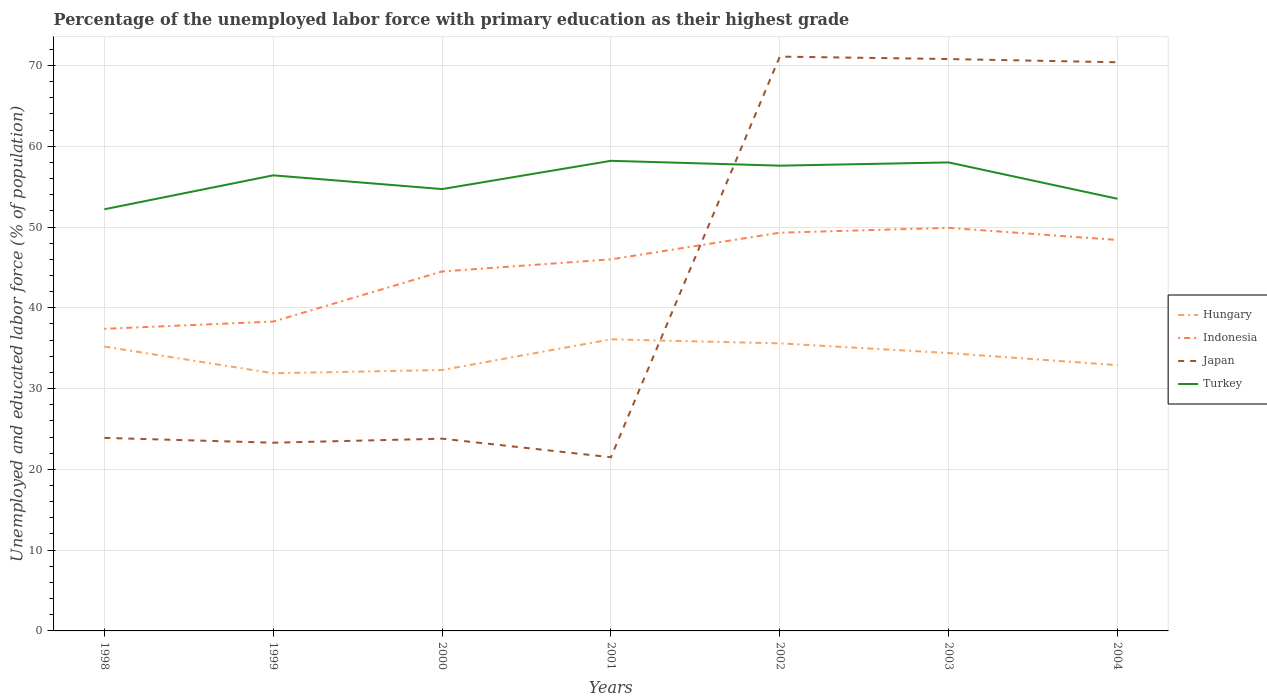Across all years, what is the maximum percentage of the unemployed labor force with primary education in Turkey?
Provide a succinct answer. 52.2. In which year was the percentage of the unemployed labor force with primary education in Indonesia maximum?
Keep it short and to the point. 1998. What is the total percentage of the unemployed labor force with primary education in Turkey in the graph?
Offer a very short reply. -0.4. What is the difference between the highest and the second highest percentage of the unemployed labor force with primary education in Hungary?
Your answer should be very brief. 4.2. What is the difference between the highest and the lowest percentage of the unemployed labor force with primary education in Japan?
Ensure brevity in your answer.  3. Is the percentage of the unemployed labor force with primary education in Turkey strictly greater than the percentage of the unemployed labor force with primary education in Hungary over the years?
Your answer should be compact. No. How many years are there in the graph?
Make the answer very short. 7. Are the values on the major ticks of Y-axis written in scientific E-notation?
Make the answer very short. No. What is the title of the graph?
Give a very brief answer. Percentage of the unemployed labor force with primary education as their highest grade. Does "Kiribati" appear as one of the legend labels in the graph?
Your answer should be very brief. No. What is the label or title of the X-axis?
Your answer should be compact. Years. What is the label or title of the Y-axis?
Your response must be concise. Unemployed and educated labor force (% of population). What is the Unemployed and educated labor force (% of population) of Hungary in 1998?
Provide a short and direct response. 35.2. What is the Unemployed and educated labor force (% of population) of Indonesia in 1998?
Your response must be concise. 37.4. What is the Unemployed and educated labor force (% of population) of Japan in 1998?
Your answer should be very brief. 23.9. What is the Unemployed and educated labor force (% of population) in Turkey in 1998?
Make the answer very short. 52.2. What is the Unemployed and educated labor force (% of population) in Hungary in 1999?
Your answer should be compact. 31.9. What is the Unemployed and educated labor force (% of population) of Indonesia in 1999?
Offer a very short reply. 38.3. What is the Unemployed and educated labor force (% of population) of Japan in 1999?
Provide a short and direct response. 23.3. What is the Unemployed and educated labor force (% of population) in Turkey in 1999?
Provide a succinct answer. 56.4. What is the Unemployed and educated labor force (% of population) in Hungary in 2000?
Provide a short and direct response. 32.3. What is the Unemployed and educated labor force (% of population) of Indonesia in 2000?
Provide a short and direct response. 44.5. What is the Unemployed and educated labor force (% of population) in Japan in 2000?
Your answer should be very brief. 23.8. What is the Unemployed and educated labor force (% of population) of Turkey in 2000?
Make the answer very short. 54.7. What is the Unemployed and educated labor force (% of population) in Hungary in 2001?
Offer a terse response. 36.1. What is the Unemployed and educated labor force (% of population) of Turkey in 2001?
Your answer should be compact. 58.2. What is the Unemployed and educated labor force (% of population) in Hungary in 2002?
Give a very brief answer. 35.6. What is the Unemployed and educated labor force (% of population) in Indonesia in 2002?
Make the answer very short. 49.3. What is the Unemployed and educated labor force (% of population) in Japan in 2002?
Your response must be concise. 71.1. What is the Unemployed and educated labor force (% of population) of Turkey in 2002?
Your answer should be compact. 57.6. What is the Unemployed and educated labor force (% of population) in Hungary in 2003?
Provide a short and direct response. 34.4. What is the Unemployed and educated labor force (% of population) of Indonesia in 2003?
Offer a very short reply. 49.9. What is the Unemployed and educated labor force (% of population) of Japan in 2003?
Provide a short and direct response. 70.8. What is the Unemployed and educated labor force (% of population) of Hungary in 2004?
Provide a succinct answer. 32.9. What is the Unemployed and educated labor force (% of population) in Indonesia in 2004?
Make the answer very short. 48.4. What is the Unemployed and educated labor force (% of population) of Japan in 2004?
Offer a terse response. 70.4. What is the Unemployed and educated labor force (% of population) in Turkey in 2004?
Make the answer very short. 53.5. Across all years, what is the maximum Unemployed and educated labor force (% of population) in Hungary?
Offer a terse response. 36.1. Across all years, what is the maximum Unemployed and educated labor force (% of population) in Indonesia?
Offer a terse response. 49.9. Across all years, what is the maximum Unemployed and educated labor force (% of population) in Japan?
Ensure brevity in your answer.  71.1. Across all years, what is the maximum Unemployed and educated labor force (% of population) in Turkey?
Keep it short and to the point. 58.2. Across all years, what is the minimum Unemployed and educated labor force (% of population) of Hungary?
Your answer should be compact. 31.9. Across all years, what is the minimum Unemployed and educated labor force (% of population) in Indonesia?
Provide a succinct answer. 37.4. Across all years, what is the minimum Unemployed and educated labor force (% of population) in Japan?
Provide a succinct answer. 21.5. Across all years, what is the minimum Unemployed and educated labor force (% of population) in Turkey?
Make the answer very short. 52.2. What is the total Unemployed and educated labor force (% of population) of Hungary in the graph?
Your answer should be compact. 238.4. What is the total Unemployed and educated labor force (% of population) in Indonesia in the graph?
Your response must be concise. 313.8. What is the total Unemployed and educated labor force (% of population) of Japan in the graph?
Ensure brevity in your answer.  304.8. What is the total Unemployed and educated labor force (% of population) of Turkey in the graph?
Your answer should be compact. 390.6. What is the difference between the Unemployed and educated labor force (% of population) of Indonesia in 1998 and that in 1999?
Keep it short and to the point. -0.9. What is the difference between the Unemployed and educated labor force (% of population) in Japan in 1998 and that in 1999?
Provide a short and direct response. 0.6. What is the difference between the Unemployed and educated labor force (% of population) of Turkey in 1998 and that in 1999?
Give a very brief answer. -4.2. What is the difference between the Unemployed and educated labor force (% of population) of Hungary in 1998 and that in 2000?
Give a very brief answer. 2.9. What is the difference between the Unemployed and educated labor force (% of population) in Japan in 1998 and that in 2000?
Make the answer very short. 0.1. What is the difference between the Unemployed and educated labor force (% of population) of Turkey in 1998 and that in 2000?
Your answer should be compact. -2.5. What is the difference between the Unemployed and educated labor force (% of population) of Hungary in 1998 and that in 2001?
Provide a short and direct response. -0.9. What is the difference between the Unemployed and educated labor force (% of population) of Indonesia in 1998 and that in 2001?
Ensure brevity in your answer.  -8.6. What is the difference between the Unemployed and educated labor force (% of population) of Japan in 1998 and that in 2001?
Provide a succinct answer. 2.4. What is the difference between the Unemployed and educated labor force (% of population) of Turkey in 1998 and that in 2001?
Offer a terse response. -6. What is the difference between the Unemployed and educated labor force (% of population) of Indonesia in 1998 and that in 2002?
Offer a very short reply. -11.9. What is the difference between the Unemployed and educated labor force (% of population) of Japan in 1998 and that in 2002?
Your answer should be very brief. -47.2. What is the difference between the Unemployed and educated labor force (% of population) in Hungary in 1998 and that in 2003?
Your response must be concise. 0.8. What is the difference between the Unemployed and educated labor force (% of population) in Japan in 1998 and that in 2003?
Keep it short and to the point. -46.9. What is the difference between the Unemployed and educated labor force (% of population) of Turkey in 1998 and that in 2003?
Provide a succinct answer. -5.8. What is the difference between the Unemployed and educated labor force (% of population) of Japan in 1998 and that in 2004?
Offer a terse response. -46.5. What is the difference between the Unemployed and educated labor force (% of population) in Hungary in 1999 and that in 2000?
Your answer should be compact. -0.4. What is the difference between the Unemployed and educated labor force (% of population) in Indonesia in 1999 and that in 2000?
Make the answer very short. -6.2. What is the difference between the Unemployed and educated labor force (% of population) in Turkey in 1999 and that in 2000?
Your answer should be very brief. 1.7. What is the difference between the Unemployed and educated labor force (% of population) in Indonesia in 1999 and that in 2001?
Provide a succinct answer. -7.7. What is the difference between the Unemployed and educated labor force (% of population) of Japan in 1999 and that in 2001?
Provide a short and direct response. 1.8. What is the difference between the Unemployed and educated labor force (% of population) of Hungary in 1999 and that in 2002?
Ensure brevity in your answer.  -3.7. What is the difference between the Unemployed and educated labor force (% of population) of Indonesia in 1999 and that in 2002?
Make the answer very short. -11. What is the difference between the Unemployed and educated labor force (% of population) of Japan in 1999 and that in 2002?
Make the answer very short. -47.8. What is the difference between the Unemployed and educated labor force (% of population) in Hungary in 1999 and that in 2003?
Offer a very short reply. -2.5. What is the difference between the Unemployed and educated labor force (% of population) in Indonesia in 1999 and that in 2003?
Provide a succinct answer. -11.6. What is the difference between the Unemployed and educated labor force (% of population) of Japan in 1999 and that in 2003?
Give a very brief answer. -47.5. What is the difference between the Unemployed and educated labor force (% of population) of Hungary in 1999 and that in 2004?
Make the answer very short. -1. What is the difference between the Unemployed and educated labor force (% of population) of Japan in 1999 and that in 2004?
Your response must be concise. -47.1. What is the difference between the Unemployed and educated labor force (% of population) in Hungary in 2000 and that in 2001?
Offer a very short reply. -3.8. What is the difference between the Unemployed and educated labor force (% of population) in Hungary in 2000 and that in 2002?
Offer a terse response. -3.3. What is the difference between the Unemployed and educated labor force (% of population) of Japan in 2000 and that in 2002?
Provide a succinct answer. -47.3. What is the difference between the Unemployed and educated labor force (% of population) of Turkey in 2000 and that in 2002?
Provide a succinct answer. -2.9. What is the difference between the Unemployed and educated labor force (% of population) of Indonesia in 2000 and that in 2003?
Give a very brief answer. -5.4. What is the difference between the Unemployed and educated labor force (% of population) of Japan in 2000 and that in 2003?
Your answer should be very brief. -47. What is the difference between the Unemployed and educated labor force (% of population) of Hungary in 2000 and that in 2004?
Keep it short and to the point. -0.6. What is the difference between the Unemployed and educated labor force (% of population) in Indonesia in 2000 and that in 2004?
Your answer should be compact. -3.9. What is the difference between the Unemployed and educated labor force (% of population) of Japan in 2000 and that in 2004?
Your answer should be very brief. -46.6. What is the difference between the Unemployed and educated labor force (% of population) of Japan in 2001 and that in 2002?
Provide a succinct answer. -49.6. What is the difference between the Unemployed and educated labor force (% of population) in Turkey in 2001 and that in 2002?
Your answer should be compact. 0.6. What is the difference between the Unemployed and educated labor force (% of population) of Japan in 2001 and that in 2003?
Provide a succinct answer. -49.3. What is the difference between the Unemployed and educated labor force (% of population) in Turkey in 2001 and that in 2003?
Ensure brevity in your answer.  0.2. What is the difference between the Unemployed and educated labor force (% of population) of Hungary in 2001 and that in 2004?
Offer a very short reply. 3.2. What is the difference between the Unemployed and educated labor force (% of population) of Japan in 2001 and that in 2004?
Provide a succinct answer. -48.9. What is the difference between the Unemployed and educated labor force (% of population) of Japan in 2002 and that in 2003?
Offer a terse response. 0.3. What is the difference between the Unemployed and educated labor force (% of population) in Turkey in 2002 and that in 2003?
Ensure brevity in your answer.  -0.4. What is the difference between the Unemployed and educated labor force (% of population) in Hungary in 2002 and that in 2004?
Give a very brief answer. 2.7. What is the difference between the Unemployed and educated labor force (% of population) in Indonesia in 2003 and that in 2004?
Make the answer very short. 1.5. What is the difference between the Unemployed and educated labor force (% of population) in Hungary in 1998 and the Unemployed and educated labor force (% of population) in Indonesia in 1999?
Keep it short and to the point. -3.1. What is the difference between the Unemployed and educated labor force (% of population) of Hungary in 1998 and the Unemployed and educated labor force (% of population) of Turkey in 1999?
Keep it short and to the point. -21.2. What is the difference between the Unemployed and educated labor force (% of population) in Japan in 1998 and the Unemployed and educated labor force (% of population) in Turkey in 1999?
Your answer should be very brief. -32.5. What is the difference between the Unemployed and educated labor force (% of population) of Hungary in 1998 and the Unemployed and educated labor force (% of population) of Indonesia in 2000?
Offer a very short reply. -9.3. What is the difference between the Unemployed and educated labor force (% of population) of Hungary in 1998 and the Unemployed and educated labor force (% of population) of Japan in 2000?
Offer a terse response. 11.4. What is the difference between the Unemployed and educated labor force (% of population) in Hungary in 1998 and the Unemployed and educated labor force (% of population) in Turkey in 2000?
Ensure brevity in your answer.  -19.5. What is the difference between the Unemployed and educated labor force (% of population) of Indonesia in 1998 and the Unemployed and educated labor force (% of population) of Japan in 2000?
Offer a very short reply. 13.6. What is the difference between the Unemployed and educated labor force (% of population) of Indonesia in 1998 and the Unemployed and educated labor force (% of population) of Turkey in 2000?
Make the answer very short. -17.3. What is the difference between the Unemployed and educated labor force (% of population) in Japan in 1998 and the Unemployed and educated labor force (% of population) in Turkey in 2000?
Ensure brevity in your answer.  -30.8. What is the difference between the Unemployed and educated labor force (% of population) of Hungary in 1998 and the Unemployed and educated labor force (% of population) of Indonesia in 2001?
Offer a terse response. -10.8. What is the difference between the Unemployed and educated labor force (% of population) of Hungary in 1998 and the Unemployed and educated labor force (% of population) of Turkey in 2001?
Provide a short and direct response. -23. What is the difference between the Unemployed and educated labor force (% of population) in Indonesia in 1998 and the Unemployed and educated labor force (% of population) in Turkey in 2001?
Your answer should be compact. -20.8. What is the difference between the Unemployed and educated labor force (% of population) in Japan in 1998 and the Unemployed and educated labor force (% of population) in Turkey in 2001?
Offer a very short reply. -34.3. What is the difference between the Unemployed and educated labor force (% of population) of Hungary in 1998 and the Unemployed and educated labor force (% of population) of Indonesia in 2002?
Ensure brevity in your answer.  -14.1. What is the difference between the Unemployed and educated labor force (% of population) in Hungary in 1998 and the Unemployed and educated labor force (% of population) in Japan in 2002?
Your answer should be very brief. -35.9. What is the difference between the Unemployed and educated labor force (% of population) of Hungary in 1998 and the Unemployed and educated labor force (% of population) of Turkey in 2002?
Offer a very short reply. -22.4. What is the difference between the Unemployed and educated labor force (% of population) in Indonesia in 1998 and the Unemployed and educated labor force (% of population) in Japan in 2002?
Ensure brevity in your answer.  -33.7. What is the difference between the Unemployed and educated labor force (% of population) in Indonesia in 1998 and the Unemployed and educated labor force (% of population) in Turkey in 2002?
Your answer should be very brief. -20.2. What is the difference between the Unemployed and educated labor force (% of population) in Japan in 1998 and the Unemployed and educated labor force (% of population) in Turkey in 2002?
Your answer should be compact. -33.7. What is the difference between the Unemployed and educated labor force (% of population) in Hungary in 1998 and the Unemployed and educated labor force (% of population) in Indonesia in 2003?
Your response must be concise. -14.7. What is the difference between the Unemployed and educated labor force (% of population) in Hungary in 1998 and the Unemployed and educated labor force (% of population) in Japan in 2003?
Keep it short and to the point. -35.6. What is the difference between the Unemployed and educated labor force (% of population) in Hungary in 1998 and the Unemployed and educated labor force (% of population) in Turkey in 2003?
Provide a succinct answer. -22.8. What is the difference between the Unemployed and educated labor force (% of population) in Indonesia in 1998 and the Unemployed and educated labor force (% of population) in Japan in 2003?
Make the answer very short. -33.4. What is the difference between the Unemployed and educated labor force (% of population) of Indonesia in 1998 and the Unemployed and educated labor force (% of population) of Turkey in 2003?
Give a very brief answer. -20.6. What is the difference between the Unemployed and educated labor force (% of population) of Japan in 1998 and the Unemployed and educated labor force (% of population) of Turkey in 2003?
Your answer should be compact. -34.1. What is the difference between the Unemployed and educated labor force (% of population) of Hungary in 1998 and the Unemployed and educated labor force (% of population) of Indonesia in 2004?
Your answer should be very brief. -13.2. What is the difference between the Unemployed and educated labor force (% of population) of Hungary in 1998 and the Unemployed and educated labor force (% of population) of Japan in 2004?
Your answer should be compact. -35.2. What is the difference between the Unemployed and educated labor force (% of population) of Hungary in 1998 and the Unemployed and educated labor force (% of population) of Turkey in 2004?
Offer a very short reply. -18.3. What is the difference between the Unemployed and educated labor force (% of population) of Indonesia in 1998 and the Unemployed and educated labor force (% of population) of Japan in 2004?
Your answer should be compact. -33. What is the difference between the Unemployed and educated labor force (% of population) in Indonesia in 1998 and the Unemployed and educated labor force (% of population) in Turkey in 2004?
Your answer should be very brief. -16.1. What is the difference between the Unemployed and educated labor force (% of population) in Japan in 1998 and the Unemployed and educated labor force (% of population) in Turkey in 2004?
Provide a short and direct response. -29.6. What is the difference between the Unemployed and educated labor force (% of population) of Hungary in 1999 and the Unemployed and educated labor force (% of population) of Japan in 2000?
Provide a short and direct response. 8.1. What is the difference between the Unemployed and educated labor force (% of population) of Hungary in 1999 and the Unemployed and educated labor force (% of population) of Turkey in 2000?
Your answer should be compact. -22.8. What is the difference between the Unemployed and educated labor force (% of population) in Indonesia in 1999 and the Unemployed and educated labor force (% of population) in Japan in 2000?
Give a very brief answer. 14.5. What is the difference between the Unemployed and educated labor force (% of population) in Indonesia in 1999 and the Unemployed and educated labor force (% of population) in Turkey in 2000?
Your answer should be compact. -16.4. What is the difference between the Unemployed and educated labor force (% of population) in Japan in 1999 and the Unemployed and educated labor force (% of population) in Turkey in 2000?
Keep it short and to the point. -31.4. What is the difference between the Unemployed and educated labor force (% of population) of Hungary in 1999 and the Unemployed and educated labor force (% of population) of Indonesia in 2001?
Offer a very short reply. -14.1. What is the difference between the Unemployed and educated labor force (% of population) of Hungary in 1999 and the Unemployed and educated labor force (% of population) of Japan in 2001?
Offer a very short reply. 10.4. What is the difference between the Unemployed and educated labor force (% of population) in Hungary in 1999 and the Unemployed and educated labor force (% of population) in Turkey in 2001?
Your response must be concise. -26.3. What is the difference between the Unemployed and educated labor force (% of population) in Indonesia in 1999 and the Unemployed and educated labor force (% of population) in Japan in 2001?
Offer a terse response. 16.8. What is the difference between the Unemployed and educated labor force (% of population) of Indonesia in 1999 and the Unemployed and educated labor force (% of population) of Turkey in 2001?
Make the answer very short. -19.9. What is the difference between the Unemployed and educated labor force (% of population) of Japan in 1999 and the Unemployed and educated labor force (% of population) of Turkey in 2001?
Provide a succinct answer. -34.9. What is the difference between the Unemployed and educated labor force (% of population) of Hungary in 1999 and the Unemployed and educated labor force (% of population) of Indonesia in 2002?
Give a very brief answer. -17.4. What is the difference between the Unemployed and educated labor force (% of population) in Hungary in 1999 and the Unemployed and educated labor force (% of population) in Japan in 2002?
Your answer should be very brief. -39.2. What is the difference between the Unemployed and educated labor force (% of population) of Hungary in 1999 and the Unemployed and educated labor force (% of population) of Turkey in 2002?
Give a very brief answer. -25.7. What is the difference between the Unemployed and educated labor force (% of population) in Indonesia in 1999 and the Unemployed and educated labor force (% of population) in Japan in 2002?
Your answer should be compact. -32.8. What is the difference between the Unemployed and educated labor force (% of population) of Indonesia in 1999 and the Unemployed and educated labor force (% of population) of Turkey in 2002?
Your response must be concise. -19.3. What is the difference between the Unemployed and educated labor force (% of population) in Japan in 1999 and the Unemployed and educated labor force (% of population) in Turkey in 2002?
Provide a succinct answer. -34.3. What is the difference between the Unemployed and educated labor force (% of population) in Hungary in 1999 and the Unemployed and educated labor force (% of population) in Japan in 2003?
Ensure brevity in your answer.  -38.9. What is the difference between the Unemployed and educated labor force (% of population) of Hungary in 1999 and the Unemployed and educated labor force (% of population) of Turkey in 2003?
Make the answer very short. -26.1. What is the difference between the Unemployed and educated labor force (% of population) of Indonesia in 1999 and the Unemployed and educated labor force (% of population) of Japan in 2003?
Ensure brevity in your answer.  -32.5. What is the difference between the Unemployed and educated labor force (% of population) of Indonesia in 1999 and the Unemployed and educated labor force (% of population) of Turkey in 2003?
Your answer should be very brief. -19.7. What is the difference between the Unemployed and educated labor force (% of population) in Japan in 1999 and the Unemployed and educated labor force (% of population) in Turkey in 2003?
Provide a succinct answer. -34.7. What is the difference between the Unemployed and educated labor force (% of population) of Hungary in 1999 and the Unemployed and educated labor force (% of population) of Indonesia in 2004?
Give a very brief answer. -16.5. What is the difference between the Unemployed and educated labor force (% of population) in Hungary in 1999 and the Unemployed and educated labor force (% of population) in Japan in 2004?
Your response must be concise. -38.5. What is the difference between the Unemployed and educated labor force (% of population) of Hungary in 1999 and the Unemployed and educated labor force (% of population) of Turkey in 2004?
Provide a succinct answer. -21.6. What is the difference between the Unemployed and educated labor force (% of population) of Indonesia in 1999 and the Unemployed and educated labor force (% of population) of Japan in 2004?
Your response must be concise. -32.1. What is the difference between the Unemployed and educated labor force (% of population) in Indonesia in 1999 and the Unemployed and educated labor force (% of population) in Turkey in 2004?
Provide a short and direct response. -15.2. What is the difference between the Unemployed and educated labor force (% of population) of Japan in 1999 and the Unemployed and educated labor force (% of population) of Turkey in 2004?
Ensure brevity in your answer.  -30.2. What is the difference between the Unemployed and educated labor force (% of population) in Hungary in 2000 and the Unemployed and educated labor force (% of population) in Indonesia in 2001?
Your response must be concise. -13.7. What is the difference between the Unemployed and educated labor force (% of population) of Hungary in 2000 and the Unemployed and educated labor force (% of population) of Japan in 2001?
Make the answer very short. 10.8. What is the difference between the Unemployed and educated labor force (% of population) in Hungary in 2000 and the Unemployed and educated labor force (% of population) in Turkey in 2001?
Ensure brevity in your answer.  -25.9. What is the difference between the Unemployed and educated labor force (% of population) in Indonesia in 2000 and the Unemployed and educated labor force (% of population) in Japan in 2001?
Your answer should be very brief. 23. What is the difference between the Unemployed and educated labor force (% of population) in Indonesia in 2000 and the Unemployed and educated labor force (% of population) in Turkey in 2001?
Your answer should be compact. -13.7. What is the difference between the Unemployed and educated labor force (% of population) in Japan in 2000 and the Unemployed and educated labor force (% of population) in Turkey in 2001?
Offer a terse response. -34.4. What is the difference between the Unemployed and educated labor force (% of population) of Hungary in 2000 and the Unemployed and educated labor force (% of population) of Indonesia in 2002?
Your response must be concise. -17. What is the difference between the Unemployed and educated labor force (% of population) in Hungary in 2000 and the Unemployed and educated labor force (% of population) in Japan in 2002?
Ensure brevity in your answer.  -38.8. What is the difference between the Unemployed and educated labor force (% of population) in Hungary in 2000 and the Unemployed and educated labor force (% of population) in Turkey in 2002?
Give a very brief answer. -25.3. What is the difference between the Unemployed and educated labor force (% of population) in Indonesia in 2000 and the Unemployed and educated labor force (% of population) in Japan in 2002?
Offer a very short reply. -26.6. What is the difference between the Unemployed and educated labor force (% of population) in Japan in 2000 and the Unemployed and educated labor force (% of population) in Turkey in 2002?
Provide a succinct answer. -33.8. What is the difference between the Unemployed and educated labor force (% of population) in Hungary in 2000 and the Unemployed and educated labor force (% of population) in Indonesia in 2003?
Offer a terse response. -17.6. What is the difference between the Unemployed and educated labor force (% of population) in Hungary in 2000 and the Unemployed and educated labor force (% of population) in Japan in 2003?
Your response must be concise. -38.5. What is the difference between the Unemployed and educated labor force (% of population) in Hungary in 2000 and the Unemployed and educated labor force (% of population) in Turkey in 2003?
Make the answer very short. -25.7. What is the difference between the Unemployed and educated labor force (% of population) of Indonesia in 2000 and the Unemployed and educated labor force (% of population) of Japan in 2003?
Make the answer very short. -26.3. What is the difference between the Unemployed and educated labor force (% of population) of Indonesia in 2000 and the Unemployed and educated labor force (% of population) of Turkey in 2003?
Offer a terse response. -13.5. What is the difference between the Unemployed and educated labor force (% of population) of Japan in 2000 and the Unemployed and educated labor force (% of population) of Turkey in 2003?
Offer a terse response. -34.2. What is the difference between the Unemployed and educated labor force (% of population) of Hungary in 2000 and the Unemployed and educated labor force (% of population) of Indonesia in 2004?
Provide a short and direct response. -16.1. What is the difference between the Unemployed and educated labor force (% of population) of Hungary in 2000 and the Unemployed and educated labor force (% of population) of Japan in 2004?
Provide a succinct answer. -38.1. What is the difference between the Unemployed and educated labor force (% of population) in Hungary in 2000 and the Unemployed and educated labor force (% of population) in Turkey in 2004?
Make the answer very short. -21.2. What is the difference between the Unemployed and educated labor force (% of population) in Indonesia in 2000 and the Unemployed and educated labor force (% of population) in Japan in 2004?
Keep it short and to the point. -25.9. What is the difference between the Unemployed and educated labor force (% of population) of Indonesia in 2000 and the Unemployed and educated labor force (% of population) of Turkey in 2004?
Provide a short and direct response. -9. What is the difference between the Unemployed and educated labor force (% of population) in Japan in 2000 and the Unemployed and educated labor force (% of population) in Turkey in 2004?
Offer a very short reply. -29.7. What is the difference between the Unemployed and educated labor force (% of population) in Hungary in 2001 and the Unemployed and educated labor force (% of population) in Indonesia in 2002?
Your response must be concise. -13.2. What is the difference between the Unemployed and educated labor force (% of population) of Hungary in 2001 and the Unemployed and educated labor force (% of population) of Japan in 2002?
Your response must be concise. -35. What is the difference between the Unemployed and educated labor force (% of population) in Hungary in 2001 and the Unemployed and educated labor force (% of population) in Turkey in 2002?
Offer a very short reply. -21.5. What is the difference between the Unemployed and educated labor force (% of population) in Indonesia in 2001 and the Unemployed and educated labor force (% of population) in Japan in 2002?
Give a very brief answer. -25.1. What is the difference between the Unemployed and educated labor force (% of population) in Indonesia in 2001 and the Unemployed and educated labor force (% of population) in Turkey in 2002?
Provide a short and direct response. -11.6. What is the difference between the Unemployed and educated labor force (% of population) in Japan in 2001 and the Unemployed and educated labor force (% of population) in Turkey in 2002?
Provide a short and direct response. -36.1. What is the difference between the Unemployed and educated labor force (% of population) in Hungary in 2001 and the Unemployed and educated labor force (% of population) in Indonesia in 2003?
Your response must be concise. -13.8. What is the difference between the Unemployed and educated labor force (% of population) of Hungary in 2001 and the Unemployed and educated labor force (% of population) of Japan in 2003?
Provide a short and direct response. -34.7. What is the difference between the Unemployed and educated labor force (% of population) in Hungary in 2001 and the Unemployed and educated labor force (% of population) in Turkey in 2003?
Your answer should be compact. -21.9. What is the difference between the Unemployed and educated labor force (% of population) in Indonesia in 2001 and the Unemployed and educated labor force (% of population) in Japan in 2003?
Ensure brevity in your answer.  -24.8. What is the difference between the Unemployed and educated labor force (% of population) in Indonesia in 2001 and the Unemployed and educated labor force (% of population) in Turkey in 2003?
Make the answer very short. -12. What is the difference between the Unemployed and educated labor force (% of population) in Japan in 2001 and the Unemployed and educated labor force (% of population) in Turkey in 2003?
Keep it short and to the point. -36.5. What is the difference between the Unemployed and educated labor force (% of population) of Hungary in 2001 and the Unemployed and educated labor force (% of population) of Japan in 2004?
Ensure brevity in your answer.  -34.3. What is the difference between the Unemployed and educated labor force (% of population) in Hungary in 2001 and the Unemployed and educated labor force (% of population) in Turkey in 2004?
Give a very brief answer. -17.4. What is the difference between the Unemployed and educated labor force (% of population) in Indonesia in 2001 and the Unemployed and educated labor force (% of population) in Japan in 2004?
Provide a short and direct response. -24.4. What is the difference between the Unemployed and educated labor force (% of population) of Japan in 2001 and the Unemployed and educated labor force (% of population) of Turkey in 2004?
Offer a very short reply. -32. What is the difference between the Unemployed and educated labor force (% of population) in Hungary in 2002 and the Unemployed and educated labor force (% of population) in Indonesia in 2003?
Provide a succinct answer. -14.3. What is the difference between the Unemployed and educated labor force (% of population) of Hungary in 2002 and the Unemployed and educated labor force (% of population) of Japan in 2003?
Give a very brief answer. -35.2. What is the difference between the Unemployed and educated labor force (% of population) of Hungary in 2002 and the Unemployed and educated labor force (% of population) of Turkey in 2003?
Offer a terse response. -22.4. What is the difference between the Unemployed and educated labor force (% of population) of Indonesia in 2002 and the Unemployed and educated labor force (% of population) of Japan in 2003?
Make the answer very short. -21.5. What is the difference between the Unemployed and educated labor force (% of population) of Japan in 2002 and the Unemployed and educated labor force (% of population) of Turkey in 2003?
Provide a short and direct response. 13.1. What is the difference between the Unemployed and educated labor force (% of population) in Hungary in 2002 and the Unemployed and educated labor force (% of population) in Japan in 2004?
Provide a succinct answer. -34.8. What is the difference between the Unemployed and educated labor force (% of population) of Hungary in 2002 and the Unemployed and educated labor force (% of population) of Turkey in 2004?
Offer a terse response. -17.9. What is the difference between the Unemployed and educated labor force (% of population) of Indonesia in 2002 and the Unemployed and educated labor force (% of population) of Japan in 2004?
Offer a very short reply. -21.1. What is the difference between the Unemployed and educated labor force (% of population) in Hungary in 2003 and the Unemployed and educated labor force (% of population) in Japan in 2004?
Offer a terse response. -36. What is the difference between the Unemployed and educated labor force (% of population) in Hungary in 2003 and the Unemployed and educated labor force (% of population) in Turkey in 2004?
Offer a very short reply. -19.1. What is the difference between the Unemployed and educated labor force (% of population) of Indonesia in 2003 and the Unemployed and educated labor force (% of population) of Japan in 2004?
Keep it short and to the point. -20.5. What is the difference between the Unemployed and educated labor force (% of population) in Japan in 2003 and the Unemployed and educated labor force (% of population) in Turkey in 2004?
Your response must be concise. 17.3. What is the average Unemployed and educated labor force (% of population) in Hungary per year?
Your response must be concise. 34.06. What is the average Unemployed and educated labor force (% of population) in Indonesia per year?
Offer a terse response. 44.83. What is the average Unemployed and educated labor force (% of population) in Japan per year?
Give a very brief answer. 43.54. What is the average Unemployed and educated labor force (% of population) in Turkey per year?
Your response must be concise. 55.8. In the year 1998, what is the difference between the Unemployed and educated labor force (% of population) in Hungary and Unemployed and educated labor force (% of population) in Indonesia?
Offer a very short reply. -2.2. In the year 1998, what is the difference between the Unemployed and educated labor force (% of population) in Hungary and Unemployed and educated labor force (% of population) in Turkey?
Provide a short and direct response. -17. In the year 1998, what is the difference between the Unemployed and educated labor force (% of population) of Indonesia and Unemployed and educated labor force (% of population) of Turkey?
Offer a terse response. -14.8. In the year 1998, what is the difference between the Unemployed and educated labor force (% of population) of Japan and Unemployed and educated labor force (% of population) of Turkey?
Offer a terse response. -28.3. In the year 1999, what is the difference between the Unemployed and educated labor force (% of population) of Hungary and Unemployed and educated labor force (% of population) of Turkey?
Make the answer very short. -24.5. In the year 1999, what is the difference between the Unemployed and educated labor force (% of population) in Indonesia and Unemployed and educated labor force (% of population) in Turkey?
Provide a short and direct response. -18.1. In the year 1999, what is the difference between the Unemployed and educated labor force (% of population) in Japan and Unemployed and educated labor force (% of population) in Turkey?
Provide a succinct answer. -33.1. In the year 2000, what is the difference between the Unemployed and educated labor force (% of population) in Hungary and Unemployed and educated labor force (% of population) in Japan?
Give a very brief answer. 8.5. In the year 2000, what is the difference between the Unemployed and educated labor force (% of population) of Hungary and Unemployed and educated labor force (% of population) of Turkey?
Your response must be concise. -22.4. In the year 2000, what is the difference between the Unemployed and educated labor force (% of population) in Indonesia and Unemployed and educated labor force (% of population) in Japan?
Provide a succinct answer. 20.7. In the year 2000, what is the difference between the Unemployed and educated labor force (% of population) in Indonesia and Unemployed and educated labor force (% of population) in Turkey?
Your answer should be very brief. -10.2. In the year 2000, what is the difference between the Unemployed and educated labor force (% of population) of Japan and Unemployed and educated labor force (% of population) of Turkey?
Make the answer very short. -30.9. In the year 2001, what is the difference between the Unemployed and educated labor force (% of population) in Hungary and Unemployed and educated labor force (% of population) in Indonesia?
Your answer should be compact. -9.9. In the year 2001, what is the difference between the Unemployed and educated labor force (% of population) of Hungary and Unemployed and educated labor force (% of population) of Turkey?
Provide a short and direct response. -22.1. In the year 2001, what is the difference between the Unemployed and educated labor force (% of population) of Indonesia and Unemployed and educated labor force (% of population) of Turkey?
Keep it short and to the point. -12.2. In the year 2001, what is the difference between the Unemployed and educated labor force (% of population) of Japan and Unemployed and educated labor force (% of population) of Turkey?
Give a very brief answer. -36.7. In the year 2002, what is the difference between the Unemployed and educated labor force (% of population) in Hungary and Unemployed and educated labor force (% of population) in Indonesia?
Provide a short and direct response. -13.7. In the year 2002, what is the difference between the Unemployed and educated labor force (% of population) of Hungary and Unemployed and educated labor force (% of population) of Japan?
Your answer should be very brief. -35.5. In the year 2002, what is the difference between the Unemployed and educated labor force (% of population) in Indonesia and Unemployed and educated labor force (% of population) in Japan?
Give a very brief answer. -21.8. In the year 2002, what is the difference between the Unemployed and educated labor force (% of population) in Japan and Unemployed and educated labor force (% of population) in Turkey?
Ensure brevity in your answer.  13.5. In the year 2003, what is the difference between the Unemployed and educated labor force (% of population) in Hungary and Unemployed and educated labor force (% of population) in Indonesia?
Provide a short and direct response. -15.5. In the year 2003, what is the difference between the Unemployed and educated labor force (% of population) in Hungary and Unemployed and educated labor force (% of population) in Japan?
Ensure brevity in your answer.  -36.4. In the year 2003, what is the difference between the Unemployed and educated labor force (% of population) of Hungary and Unemployed and educated labor force (% of population) of Turkey?
Your answer should be compact. -23.6. In the year 2003, what is the difference between the Unemployed and educated labor force (% of population) in Indonesia and Unemployed and educated labor force (% of population) in Japan?
Provide a short and direct response. -20.9. In the year 2003, what is the difference between the Unemployed and educated labor force (% of population) of Japan and Unemployed and educated labor force (% of population) of Turkey?
Provide a short and direct response. 12.8. In the year 2004, what is the difference between the Unemployed and educated labor force (% of population) of Hungary and Unemployed and educated labor force (% of population) of Indonesia?
Offer a very short reply. -15.5. In the year 2004, what is the difference between the Unemployed and educated labor force (% of population) in Hungary and Unemployed and educated labor force (% of population) in Japan?
Your answer should be compact. -37.5. In the year 2004, what is the difference between the Unemployed and educated labor force (% of population) of Hungary and Unemployed and educated labor force (% of population) of Turkey?
Keep it short and to the point. -20.6. In the year 2004, what is the difference between the Unemployed and educated labor force (% of population) in Indonesia and Unemployed and educated labor force (% of population) in Turkey?
Your answer should be very brief. -5.1. In the year 2004, what is the difference between the Unemployed and educated labor force (% of population) of Japan and Unemployed and educated labor force (% of population) of Turkey?
Offer a terse response. 16.9. What is the ratio of the Unemployed and educated labor force (% of population) in Hungary in 1998 to that in 1999?
Your answer should be compact. 1.1. What is the ratio of the Unemployed and educated labor force (% of population) in Indonesia in 1998 to that in 1999?
Your response must be concise. 0.98. What is the ratio of the Unemployed and educated labor force (% of population) of Japan in 1998 to that in 1999?
Your answer should be compact. 1.03. What is the ratio of the Unemployed and educated labor force (% of population) in Turkey in 1998 to that in 1999?
Offer a terse response. 0.93. What is the ratio of the Unemployed and educated labor force (% of population) in Hungary in 1998 to that in 2000?
Keep it short and to the point. 1.09. What is the ratio of the Unemployed and educated labor force (% of population) of Indonesia in 1998 to that in 2000?
Provide a succinct answer. 0.84. What is the ratio of the Unemployed and educated labor force (% of population) of Turkey in 1998 to that in 2000?
Your response must be concise. 0.95. What is the ratio of the Unemployed and educated labor force (% of population) in Hungary in 1998 to that in 2001?
Offer a terse response. 0.98. What is the ratio of the Unemployed and educated labor force (% of population) of Indonesia in 1998 to that in 2001?
Provide a succinct answer. 0.81. What is the ratio of the Unemployed and educated labor force (% of population) of Japan in 1998 to that in 2001?
Your answer should be very brief. 1.11. What is the ratio of the Unemployed and educated labor force (% of population) of Turkey in 1998 to that in 2001?
Ensure brevity in your answer.  0.9. What is the ratio of the Unemployed and educated labor force (% of population) in Indonesia in 1998 to that in 2002?
Offer a terse response. 0.76. What is the ratio of the Unemployed and educated labor force (% of population) in Japan in 1998 to that in 2002?
Provide a short and direct response. 0.34. What is the ratio of the Unemployed and educated labor force (% of population) in Turkey in 1998 to that in 2002?
Offer a very short reply. 0.91. What is the ratio of the Unemployed and educated labor force (% of population) in Hungary in 1998 to that in 2003?
Your answer should be very brief. 1.02. What is the ratio of the Unemployed and educated labor force (% of population) of Indonesia in 1998 to that in 2003?
Your answer should be very brief. 0.75. What is the ratio of the Unemployed and educated labor force (% of population) in Japan in 1998 to that in 2003?
Give a very brief answer. 0.34. What is the ratio of the Unemployed and educated labor force (% of population) in Hungary in 1998 to that in 2004?
Your response must be concise. 1.07. What is the ratio of the Unemployed and educated labor force (% of population) in Indonesia in 1998 to that in 2004?
Your response must be concise. 0.77. What is the ratio of the Unemployed and educated labor force (% of population) of Japan in 1998 to that in 2004?
Provide a succinct answer. 0.34. What is the ratio of the Unemployed and educated labor force (% of population) of Turkey in 1998 to that in 2004?
Offer a terse response. 0.98. What is the ratio of the Unemployed and educated labor force (% of population) of Hungary in 1999 to that in 2000?
Keep it short and to the point. 0.99. What is the ratio of the Unemployed and educated labor force (% of population) of Indonesia in 1999 to that in 2000?
Provide a short and direct response. 0.86. What is the ratio of the Unemployed and educated labor force (% of population) in Turkey in 1999 to that in 2000?
Your answer should be very brief. 1.03. What is the ratio of the Unemployed and educated labor force (% of population) in Hungary in 1999 to that in 2001?
Provide a short and direct response. 0.88. What is the ratio of the Unemployed and educated labor force (% of population) in Indonesia in 1999 to that in 2001?
Offer a terse response. 0.83. What is the ratio of the Unemployed and educated labor force (% of population) in Japan in 1999 to that in 2001?
Your answer should be very brief. 1.08. What is the ratio of the Unemployed and educated labor force (% of population) in Turkey in 1999 to that in 2001?
Ensure brevity in your answer.  0.97. What is the ratio of the Unemployed and educated labor force (% of population) in Hungary in 1999 to that in 2002?
Offer a terse response. 0.9. What is the ratio of the Unemployed and educated labor force (% of population) in Indonesia in 1999 to that in 2002?
Offer a terse response. 0.78. What is the ratio of the Unemployed and educated labor force (% of population) of Japan in 1999 to that in 2002?
Provide a succinct answer. 0.33. What is the ratio of the Unemployed and educated labor force (% of population) of Turkey in 1999 to that in 2002?
Give a very brief answer. 0.98. What is the ratio of the Unemployed and educated labor force (% of population) in Hungary in 1999 to that in 2003?
Provide a short and direct response. 0.93. What is the ratio of the Unemployed and educated labor force (% of population) of Indonesia in 1999 to that in 2003?
Make the answer very short. 0.77. What is the ratio of the Unemployed and educated labor force (% of population) in Japan in 1999 to that in 2003?
Provide a succinct answer. 0.33. What is the ratio of the Unemployed and educated labor force (% of population) of Turkey in 1999 to that in 2003?
Give a very brief answer. 0.97. What is the ratio of the Unemployed and educated labor force (% of population) of Hungary in 1999 to that in 2004?
Your response must be concise. 0.97. What is the ratio of the Unemployed and educated labor force (% of population) in Indonesia in 1999 to that in 2004?
Keep it short and to the point. 0.79. What is the ratio of the Unemployed and educated labor force (% of population) of Japan in 1999 to that in 2004?
Make the answer very short. 0.33. What is the ratio of the Unemployed and educated labor force (% of population) in Turkey in 1999 to that in 2004?
Your answer should be compact. 1.05. What is the ratio of the Unemployed and educated labor force (% of population) of Hungary in 2000 to that in 2001?
Your response must be concise. 0.89. What is the ratio of the Unemployed and educated labor force (% of population) in Indonesia in 2000 to that in 2001?
Provide a short and direct response. 0.97. What is the ratio of the Unemployed and educated labor force (% of population) in Japan in 2000 to that in 2001?
Provide a succinct answer. 1.11. What is the ratio of the Unemployed and educated labor force (% of population) in Turkey in 2000 to that in 2001?
Provide a short and direct response. 0.94. What is the ratio of the Unemployed and educated labor force (% of population) in Hungary in 2000 to that in 2002?
Make the answer very short. 0.91. What is the ratio of the Unemployed and educated labor force (% of population) in Indonesia in 2000 to that in 2002?
Provide a short and direct response. 0.9. What is the ratio of the Unemployed and educated labor force (% of population) of Japan in 2000 to that in 2002?
Ensure brevity in your answer.  0.33. What is the ratio of the Unemployed and educated labor force (% of population) of Turkey in 2000 to that in 2002?
Offer a terse response. 0.95. What is the ratio of the Unemployed and educated labor force (% of population) in Hungary in 2000 to that in 2003?
Provide a succinct answer. 0.94. What is the ratio of the Unemployed and educated labor force (% of population) in Indonesia in 2000 to that in 2003?
Provide a succinct answer. 0.89. What is the ratio of the Unemployed and educated labor force (% of population) in Japan in 2000 to that in 2003?
Offer a terse response. 0.34. What is the ratio of the Unemployed and educated labor force (% of population) in Turkey in 2000 to that in 2003?
Provide a short and direct response. 0.94. What is the ratio of the Unemployed and educated labor force (% of population) of Hungary in 2000 to that in 2004?
Offer a very short reply. 0.98. What is the ratio of the Unemployed and educated labor force (% of population) in Indonesia in 2000 to that in 2004?
Keep it short and to the point. 0.92. What is the ratio of the Unemployed and educated labor force (% of population) of Japan in 2000 to that in 2004?
Offer a terse response. 0.34. What is the ratio of the Unemployed and educated labor force (% of population) of Turkey in 2000 to that in 2004?
Provide a succinct answer. 1.02. What is the ratio of the Unemployed and educated labor force (% of population) of Hungary in 2001 to that in 2002?
Your response must be concise. 1.01. What is the ratio of the Unemployed and educated labor force (% of population) in Indonesia in 2001 to that in 2002?
Ensure brevity in your answer.  0.93. What is the ratio of the Unemployed and educated labor force (% of population) in Japan in 2001 to that in 2002?
Offer a terse response. 0.3. What is the ratio of the Unemployed and educated labor force (% of population) in Turkey in 2001 to that in 2002?
Make the answer very short. 1.01. What is the ratio of the Unemployed and educated labor force (% of population) in Hungary in 2001 to that in 2003?
Provide a short and direct response. 1.05. What is the ratio of the Unemployed and educated labor force (% of population) of Indonesia in 2001 to that in 2003?
Your answer should be compact. 0.92. What is the ratio of the Unemployed and educated labor force (% of population) of Japan in 2001 to that in 2003?
Give a very brief answer. 0.3. What is the ratio of the Unemployed and educated labor force (% of population) in Turkey in 2001 to that in 2003?
Offer a very short reply. 1. What is the ratio of the Unemployed and educated labor force (% of population) of Hungary in 2001 to that in 2004?
Provide a succinct answer. 1.1. What is the ratio of the Unemployed and educated labor force (% of population) of Indonesia in 2001 to that in 2004?
Your response must be concise. 0.95. What is the ratio of the Unemployed and educated labor force (% of population) of Japan in 2001 to that in 2004?
Your response must be concise. 0.31. What is the ratio of the Unemployed and educated labor force (% of population) in Turkey in 2001 to that in 2004?
Provide a succinct answer. 1.09. What is the ratio of the Unemployed and educated labor force (% of population) of Hungary in 2002 to that in 2003?
Provide a succinct answer. 1.03. What is the ratio of the Unemployed and educated labor force (% of population) of Turkey in 2002 to that in 2003?
Offer a very short reply. 0.99. What is the ratio of the Unemployed and educated labor force (% of population) of Hungary in 2002 to that in 2004?
Ensure brevity in your answer.  1.08. What is the ratio of the Unemployed and educated labor force (% of population) of Indonesia in 2002 to that in 2004?
Offer a terse response. 1.02. What is the ratio of the Unemployed and educated labor force (% of population) in Japan in 2002 to that in 2004?
Offer a terse response. 1.01. What is the ratio of the Unemployed and educated labor force (% of population) in Turkey in 2002 to that in 2004?
Give a very brief answer. 1.08. What is the ratio of the Unemployed and educated labor force (% of population) in Hungary in 2003 to that in 2004?
Keep it short and to the point. 1.05. What is the ratio of the Unemployed and educated labor force (% of population) of Indonesia in 2003 to that in 2004?
Make the answer very short. 1.03. What is the ratio of the Unemployed and educated labor force (% of population) in Japan in 2003 to that in 2004?
Offer a very short reply. 1.01. What is the ratio of the Unemployed and educated labor force (% of population) of Turkey in 2003 to that in 2004?
Give a very brief answer. 1.08. What is the difference between the highest and the second highest Unemployed and educated labor force (% of population) of Hungary?
Give a very brief answer. 0.5. What is the difference between the highest and the second highest Unemployed and educated labor force (% of population) of Indonesia?
Offer a terse response. 0.6. What is the difference between the highest and the second highest Unemployed and educated labor force (% of population) in Japan?
Keep it short and to the point. 0.3. What is the difference between the highest and the second highest Unemployed and educated labor force (% of population) of Turkey?
Offer a very short reply. 0.2. What is the difference between the highest and the lowest Unemployed and educated labor force (% of population) of Hungary?
Provide a short and direct response. 4.2. What is the difference between the highest and the lowest Unemployed and educated labor force (% of population) in Japan?
Ensure brevity in your answer.  49.6. What is the difference between the highest and the lowest Unemployed and educated labor force (% of population) of Turkey?
Provide a succinct answer. 6. 